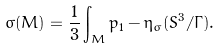<formula> <loc_0><loc_0><loc_500><loc_500>\sigma ( M ) = \frac { 1 } { 3 } \int _ { M } p _ { 1 } - \eta _ { \sigma } ( S ^ { 3 } / \Gamma ) .</formula> 